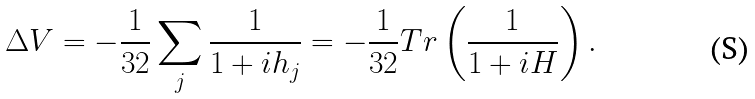Convert formula to latex. <formula><loc_0><loc_0><loc_500><loc_500>\Delta V = - \frac { 1 } { 3 2 } \sum _ { j } \frac { 1 } { 1 + i h _ { j } } = - \frac { 1 } { 3 2 } T r \left ( \frac { 1 } { 1 + i H } \right ) .</formula> 